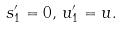<formula> <loc_0><loc_0><loc_500><loc_500>s _ { 1 } ^ { \prime } = 0 , \, u _ { 1 } ^ { \prime } = u .</formula> 